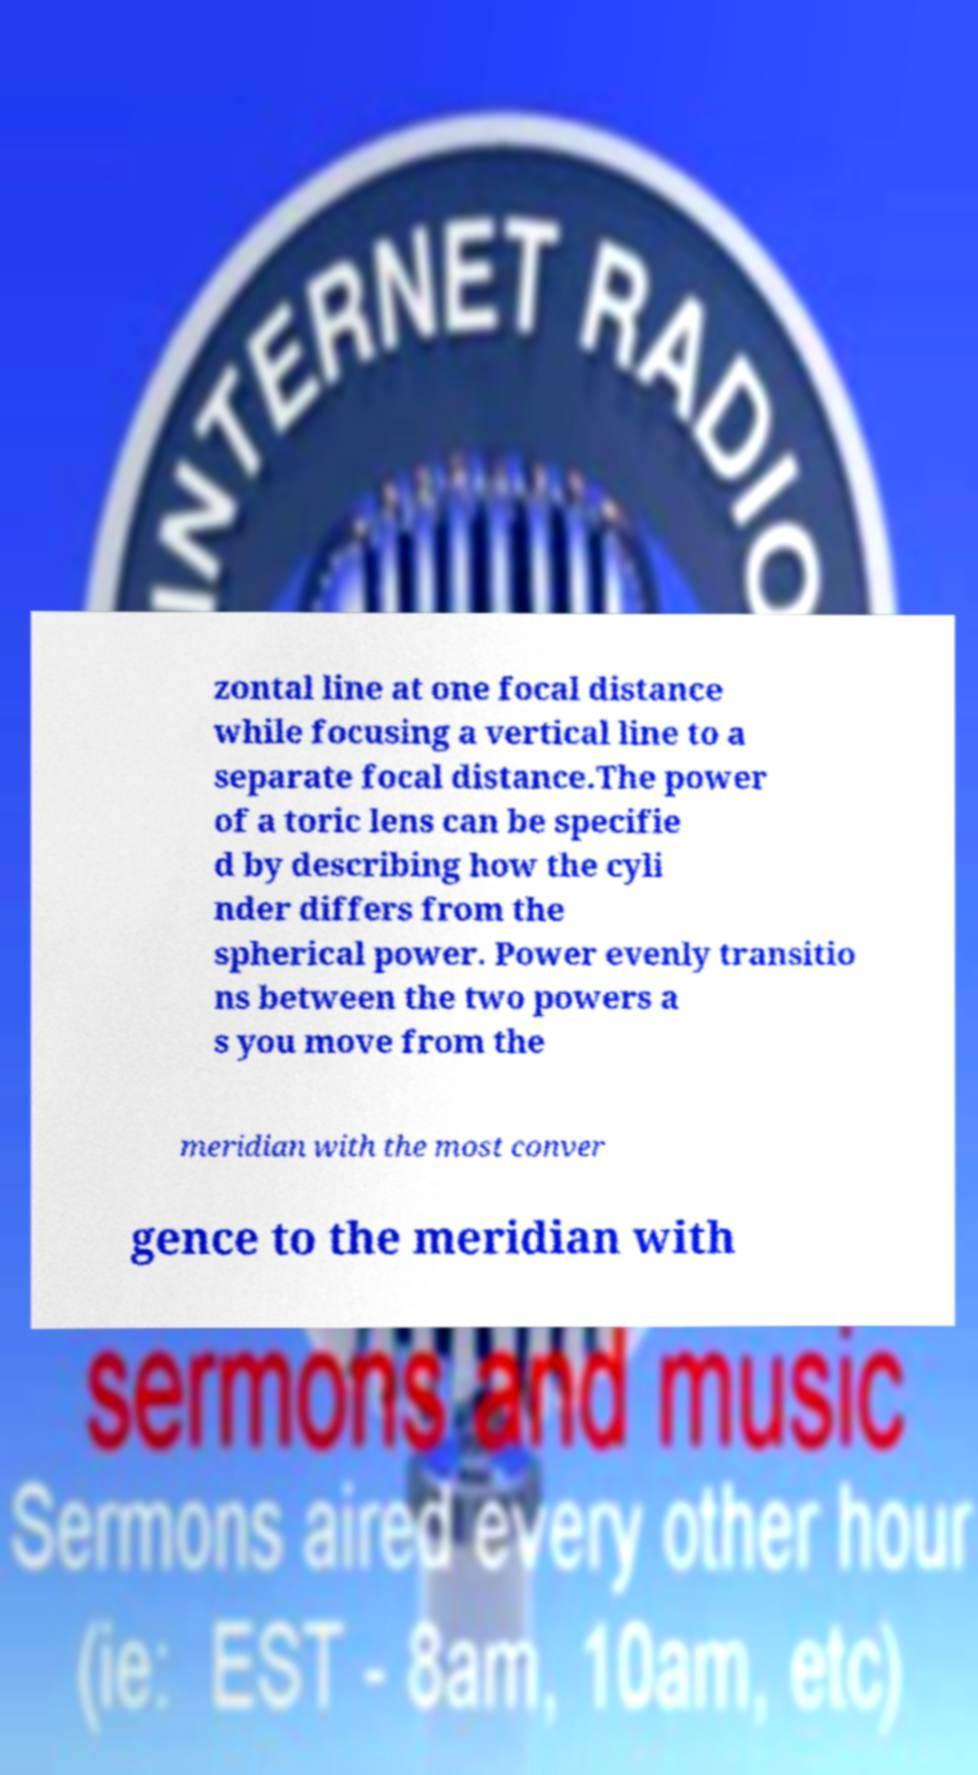Please identify and transcribe the text found in this image. zontal line at one focal distance while focusing a vertical line to a separate focal distance.The power of a toric lens can be specifie d by describing how the cyli nder differs from the spherical power. Power evenly transitio ns between the two powers a s you move from the meridian with the most conver gence to the meridian with 